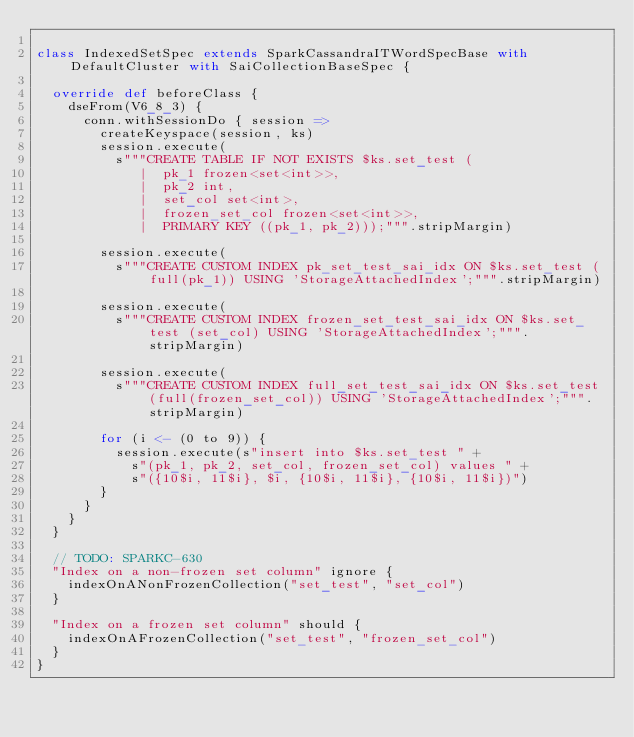<code> <loc_0><loc_0><loc_500><loc_500><_Scala_>
class IndexedSetSpec extends SparkCassandraITWordSpecBase with DefaultCluster with SaiCollectionBaseSpec {

  override def beforeClass {
    dseFrom(V6_8_3) {
      conn.withSessionDo { session =>
        createKeyspace(session, ks)
        session.execute(
          s"""CREATE TABLE IF NOT EXISTS $ks.set_test (
             |  pk_1 frozen<set<int>>,
             |  pk_2 int,
             |  set_col set<int>,
             |  frozen_set_col frozen<set<int>>,
             |  PRIMARY KEY ((pk_1, pk_2)));""".stripMargin)

        session.execute(
          s"""CREATE CUSTOM INDEX pk_set_test_sai_idx ON $ks.set_test (full(pk_1)) USING 'StorageAttachedIndex';""".stripMargin)

        session.execute(
          s"""CREATE CUSTOM INDEX frozen_set_test_sai_idx ON $ks.set_test (set_col) USING 'StorageAttachedIndex';""".stripMargin)

        session.execute(
          s"""CREATE CUSTOM INDEX full_set_test_sai_idx ON $ks.set_test (full(frozen_set_col)) USING 'StorageAttachedIndex';""".stripMargin)

        for (i <- (0 to 9)) {
          session.execute(s"insert into $ks.set_test " +
            s"(pk_1, pk_2, set_col, frozen_set_col) values " +
            s"({10$i, 11$i}, $i, {10$i, 11$i}, {10$i, 11$i})")
        }
      }
    }
  }

  // TODO: SPARKC-630
  "Index on a non-frozen set column" ignore {
    indexOnANonFrozenCollection("set_test", "set_col")
  }

  "Index on a frozen set column" should {
    indexOnAFrozenCollection("set_test", "frozen_set_col")
  }
}
</code> 